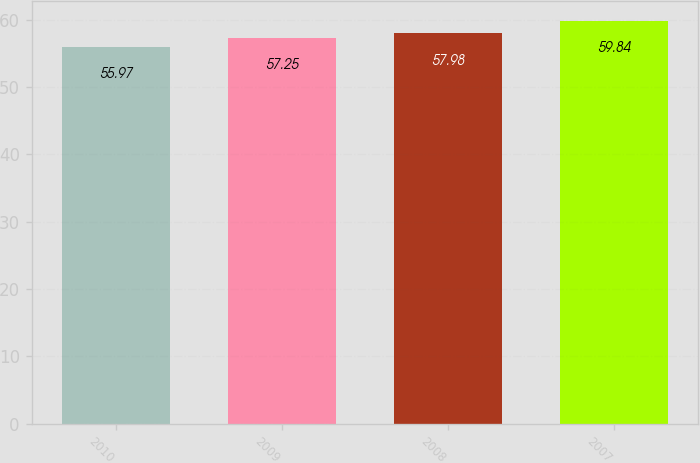<chart> <loc_0><loc_0><loc_500><loc_500><bar_chart><fcel>2010<fcel>2009<fcel>2008<fcel>2007<nl><fcel>55.97<fcel>57.25<fcel>57.98<fcel>59.84<nl></chart> 